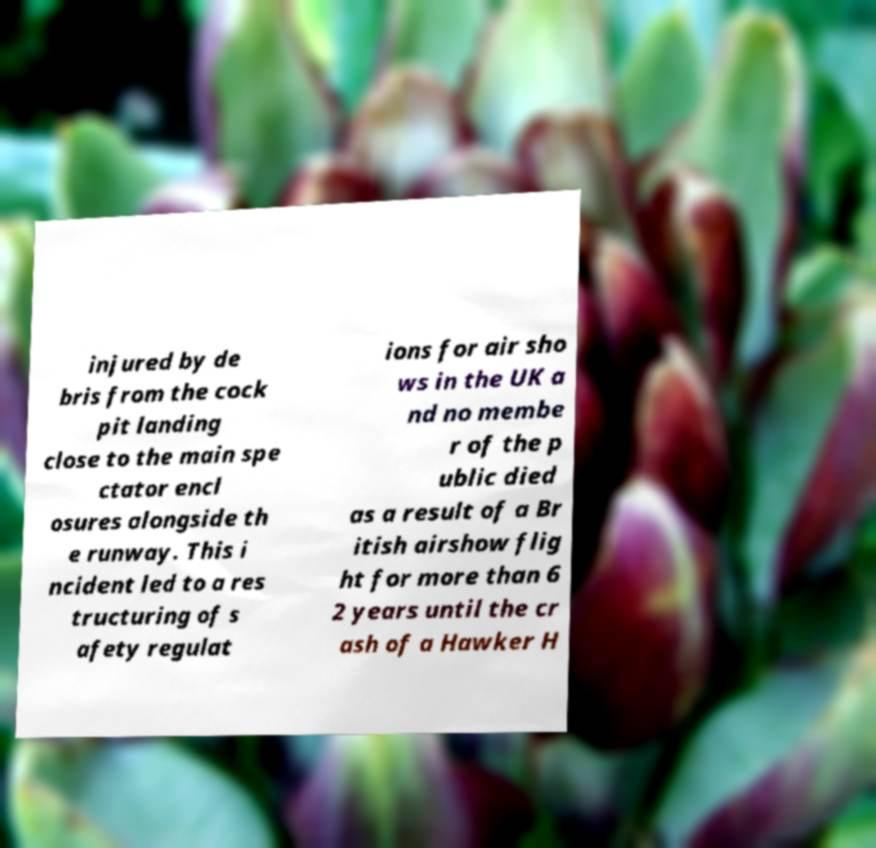There's text embedded in this image that I need extracted. Can you transcribe it verbatim? injured by de bris from the cock pit landing close to the main spe ctator encl osures alongside th e runway. This i ncident led to a res tructuring of s afety regulat ions for air sho ws in the UK a nd no membe r of the p ublic died as a result of a Br itish airshow flig ht for more than 6 2 years until the cr ash of a Hawker H 